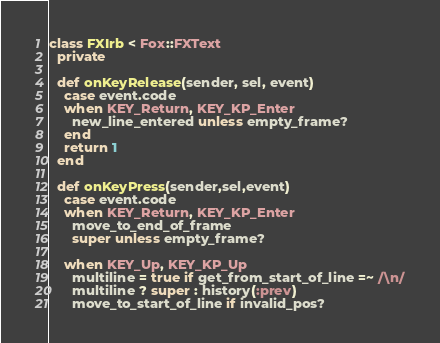<code> <loc_0><loc_0><loc_500><loc_500><_Ruby_>class FXIrb < Fox::FXText
  private

  def onKeyRelease(sender, sel, event)
    case event.code
    when KEY_Return, KEY_KP_Enter
      new_line_entered unless empty_frame?
    end
    return 1
  end

  def onKeyPress(sender,sel,event)
    case event.code
    when KEY_Return, KEY_KP_Enter
      move_to_end_of_frame
      super unless empty_frame?

    when KEY_Up, KEY_KP_Up
      multiline = true if get_from_start_of_line =~ /\n/
      multiline ? super : history(:prev)
      move_to_start_of_line if invalid_pos?
</code> 